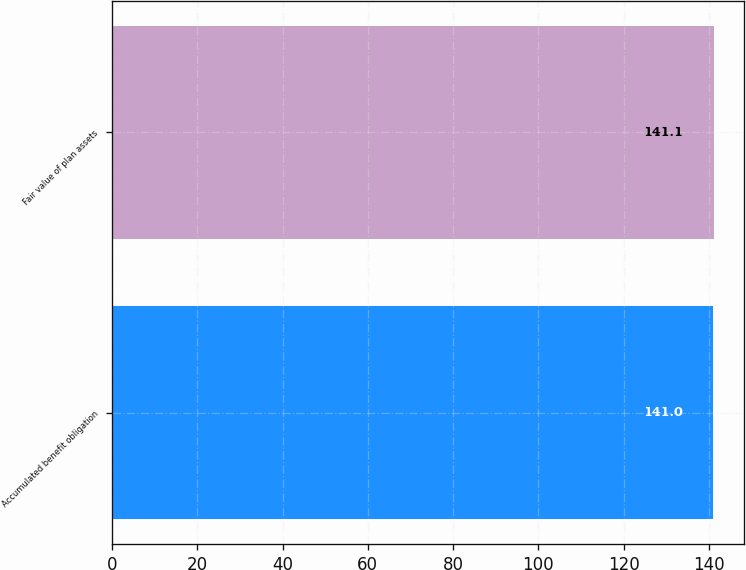Convert chart. <chart><loc_0><loc_0><loc_500><loc_500><bar_chart><fcel>Accumulated benefit obligation<fcel>Fair value of plan assets<nl><fcel>141<fcel>141.1<nl></chart> 